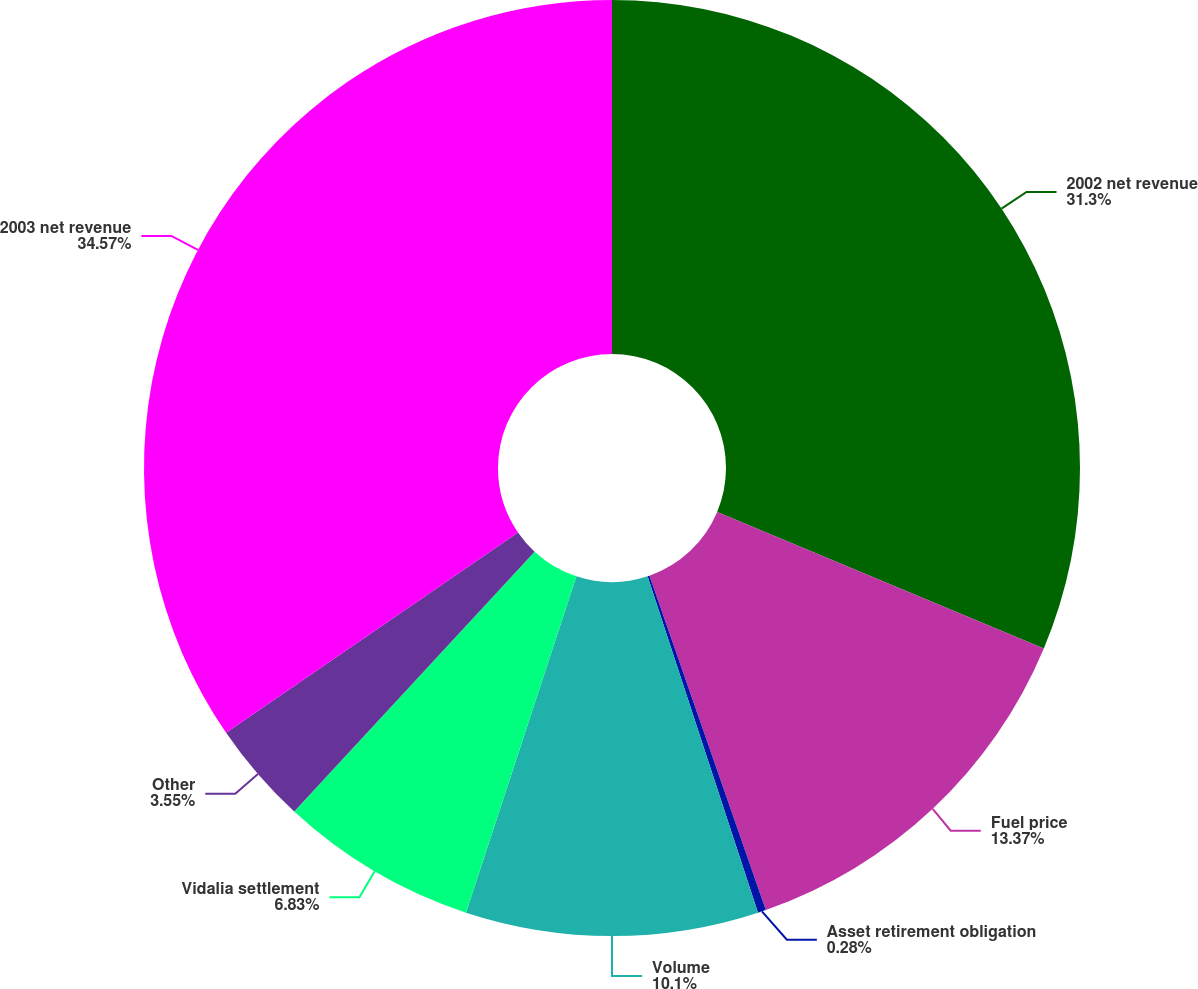<chart> <loc_0><loc_0><loc_500><loc_500><pie_chart><fcel>2002 net revenue<fcel>Fuel price<fcel>Asset retirement obligation<fcel>Volume<fcel>Vidalia settlement<fcel>Other<fcel>2003 net revenue<nl><fcel>31.3%<fcel>13.37%<fcel>0.28%<fcel>10.1%<fcel>6.83%<fcel>3.55%<fcel>34.57%<nl></chart> 